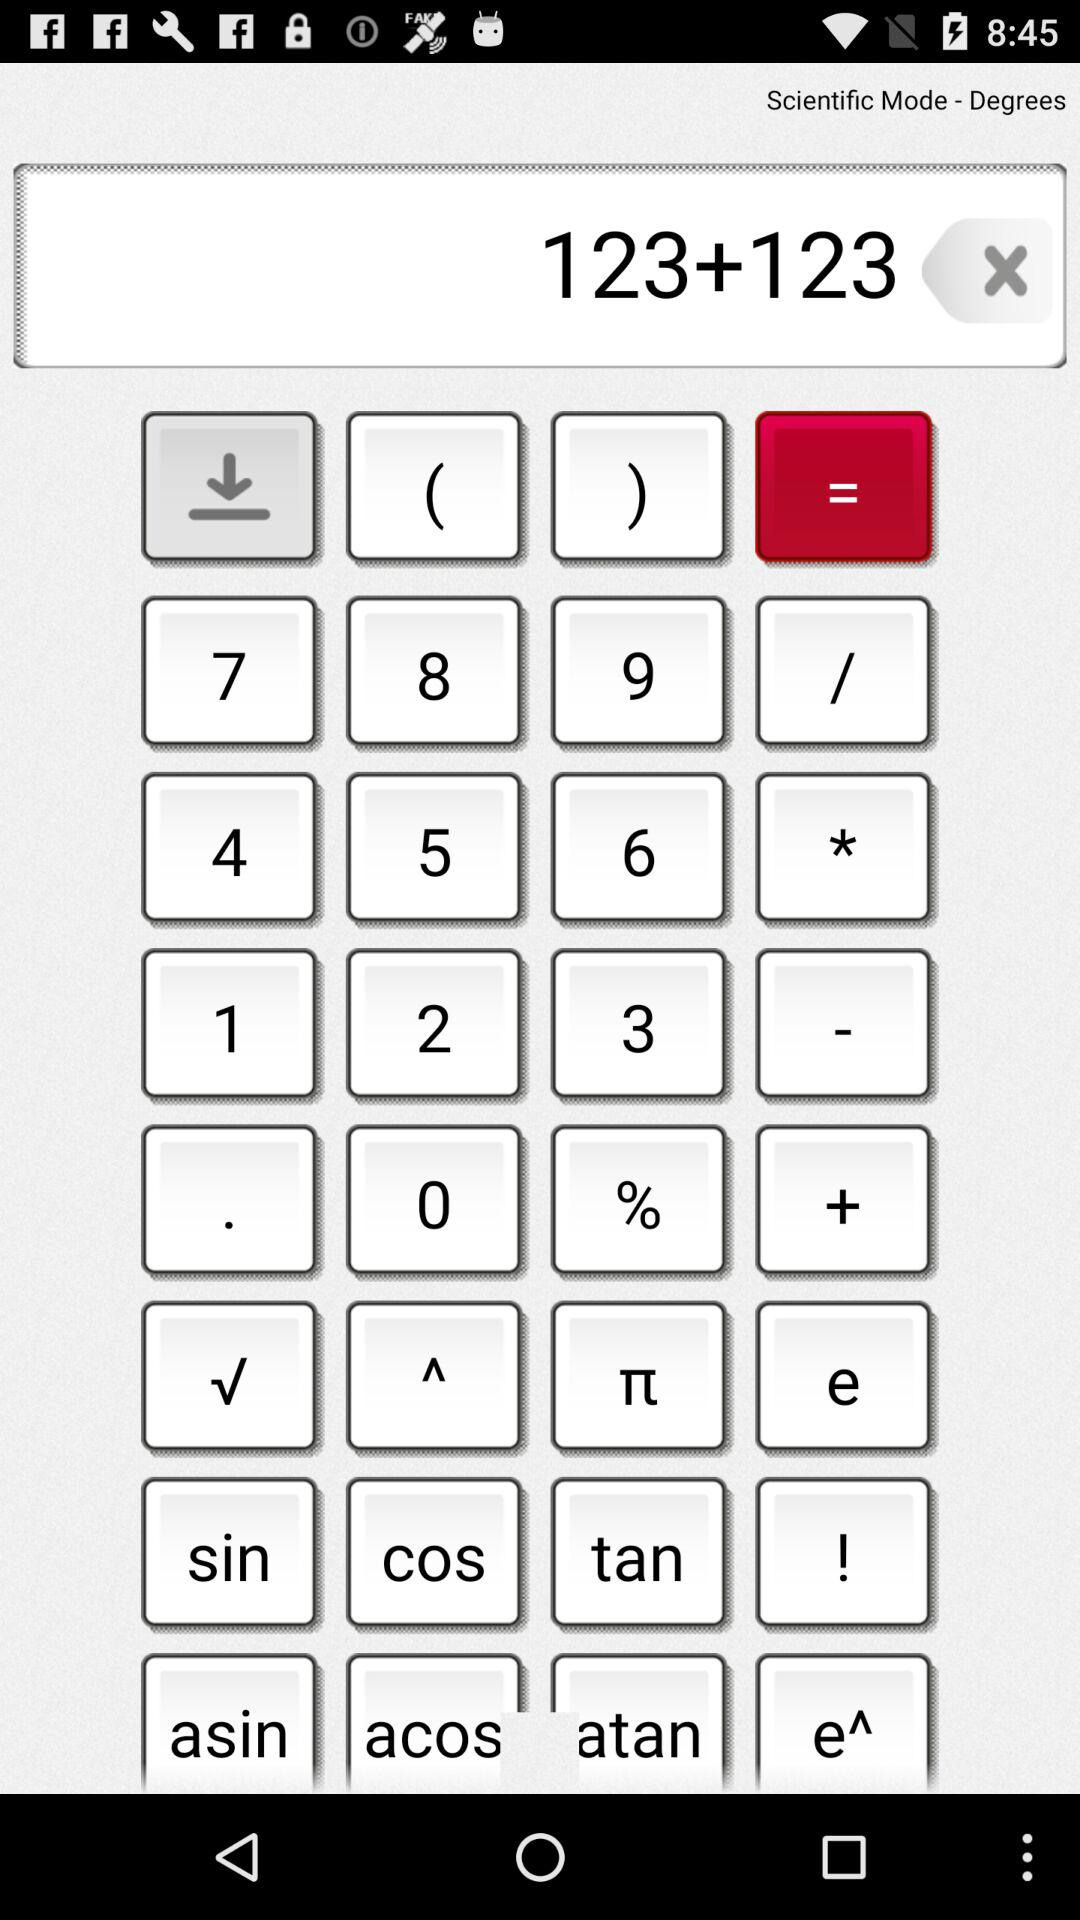What is the sum of the numbers in the text input?
Answer the question using a single word or phrase. 246 